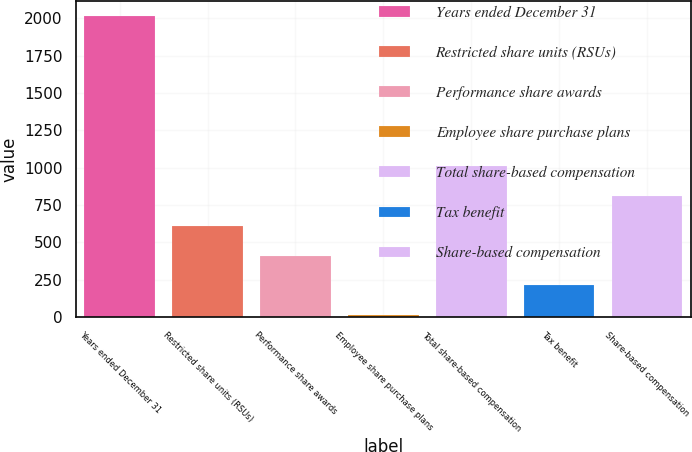<chart> <loc_0><loc_0><loc_500><loc_500><bar_chart><fcel>Years ended December 31<fcel>Restricted share units (RSUs)<fcel>Performance share awards<fcel>Employee share purchase plans<fcel>Total share-based compensation<fcel>Tax benefit<fcel>Share-based compensation<nl><fcel>2017<fcel>612.1<fcel>411.4<fcel>10<fcel>1013.5<fcel>210.7<fcel>812.8<nl></chart> 